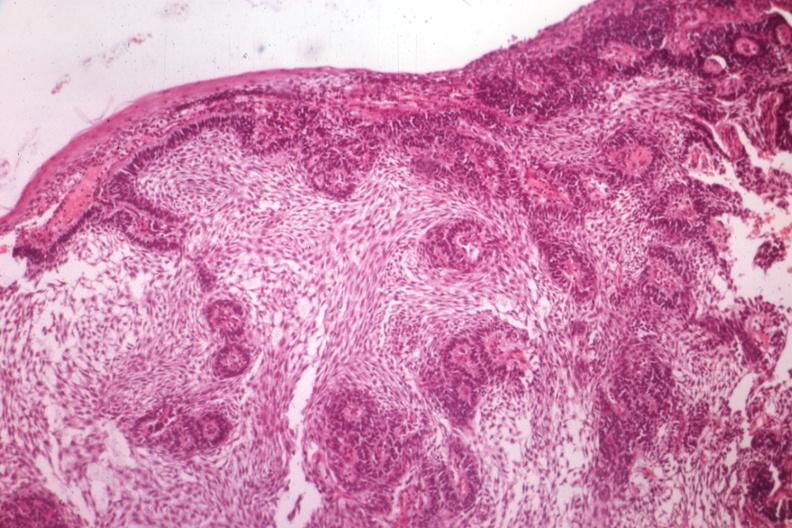what is present?
Answer the question using a single word or phrase. Bone, mandible 